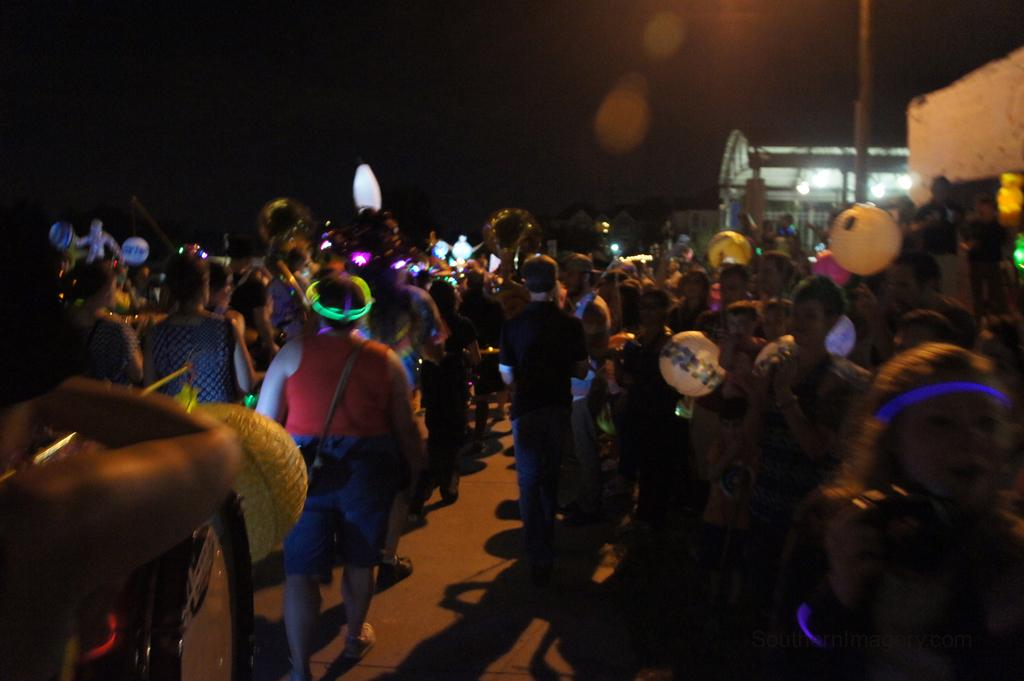What are the people in the image doing? There are people standing and walking in the image. What structure can be seen in the image? There is a building in the image. What is visible in the background of the image? The sky is visible in the image. Where is the faucet located in the image? There is no faucet present in the image. How many friends are visible in the image? The term "friends" is not mentioned in the provided facts, so it cannot be determined from the image. 